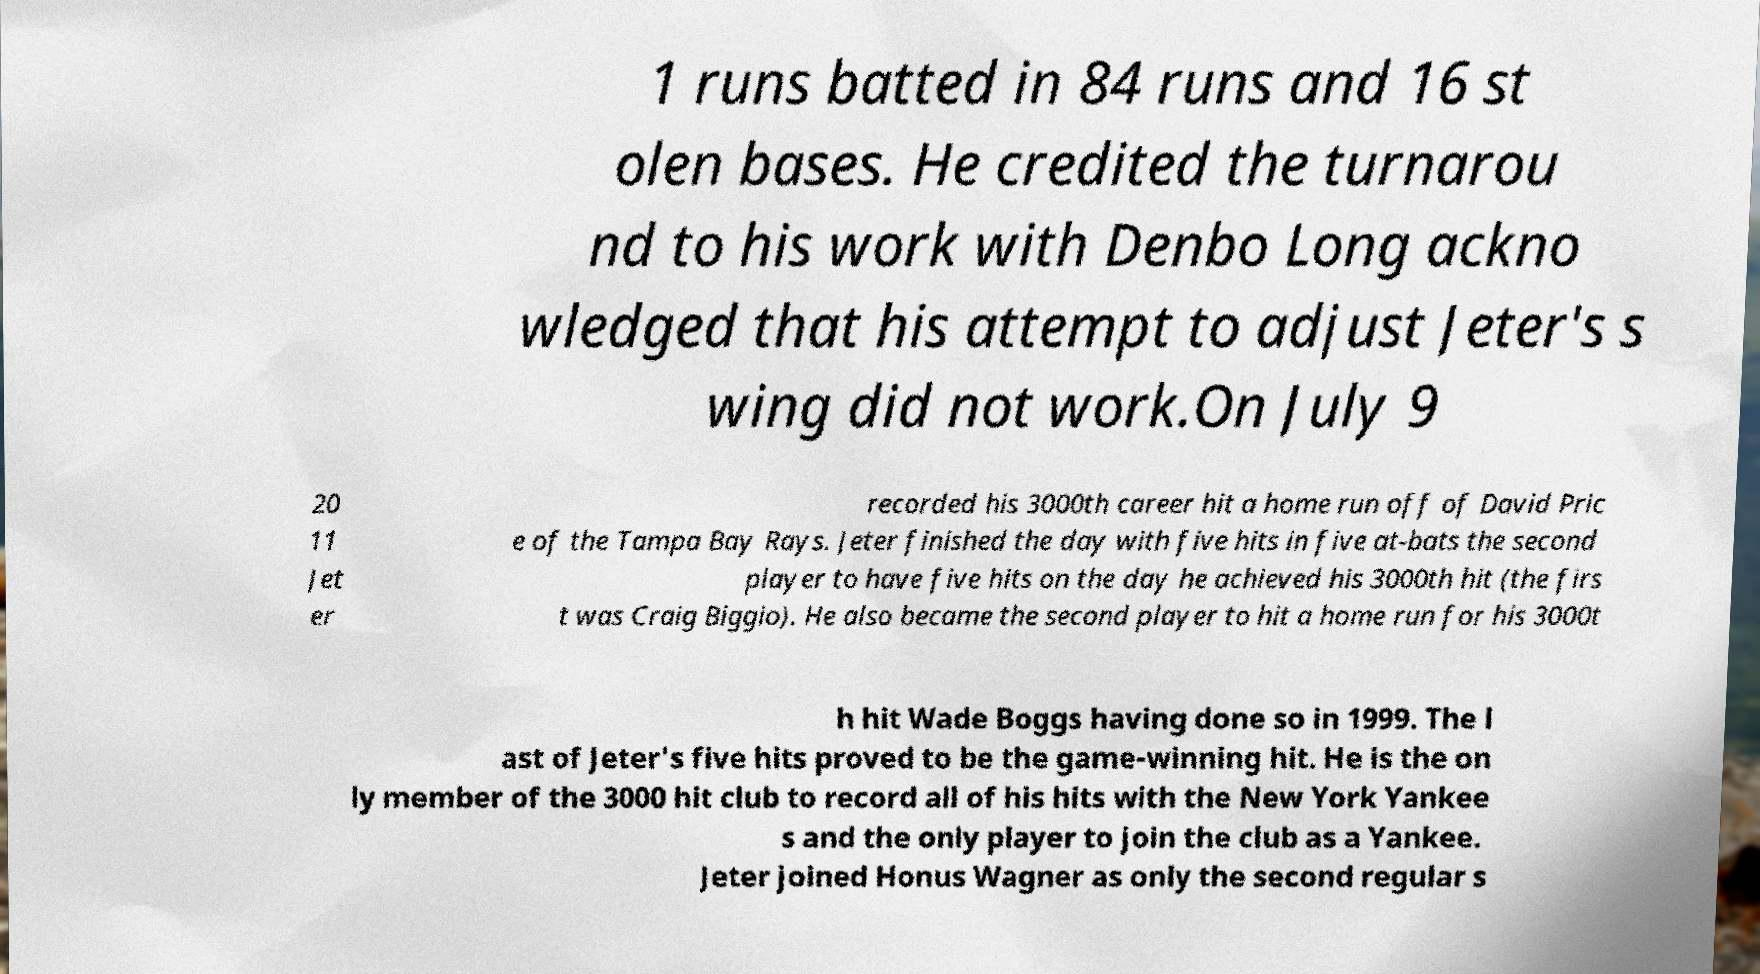Could you assist in decoding the text presented in this image and type it out clearly? 1 runs batted in 84 runs and 16 st olen bases. He credited the turnarou nd to his work with Denbo Long ackno wledged that his attempt to adjust Jeter's s wing did not work.On July 9 20 11 Jet er recorded his 3000th career hit a home run off of David Pric e of the Tampa Bay Rays. Jeter finished the day with five hits in five at-bats the second player to have five hits on the day he achieved his 3000th hit (the firs t was Craig Biggio). He also became the second player to hit a home run for his 3000t h hit Wade Boggs having done so in 1999. The l ast of Jeter's five hits proved to be the game-winning hit. He is the on ly member of the 3000 hit club to record all of his hits with the New York Yankee s and the only player to join the club as a Yankee. Jeter joined Honus Wagner as only the second regular s 